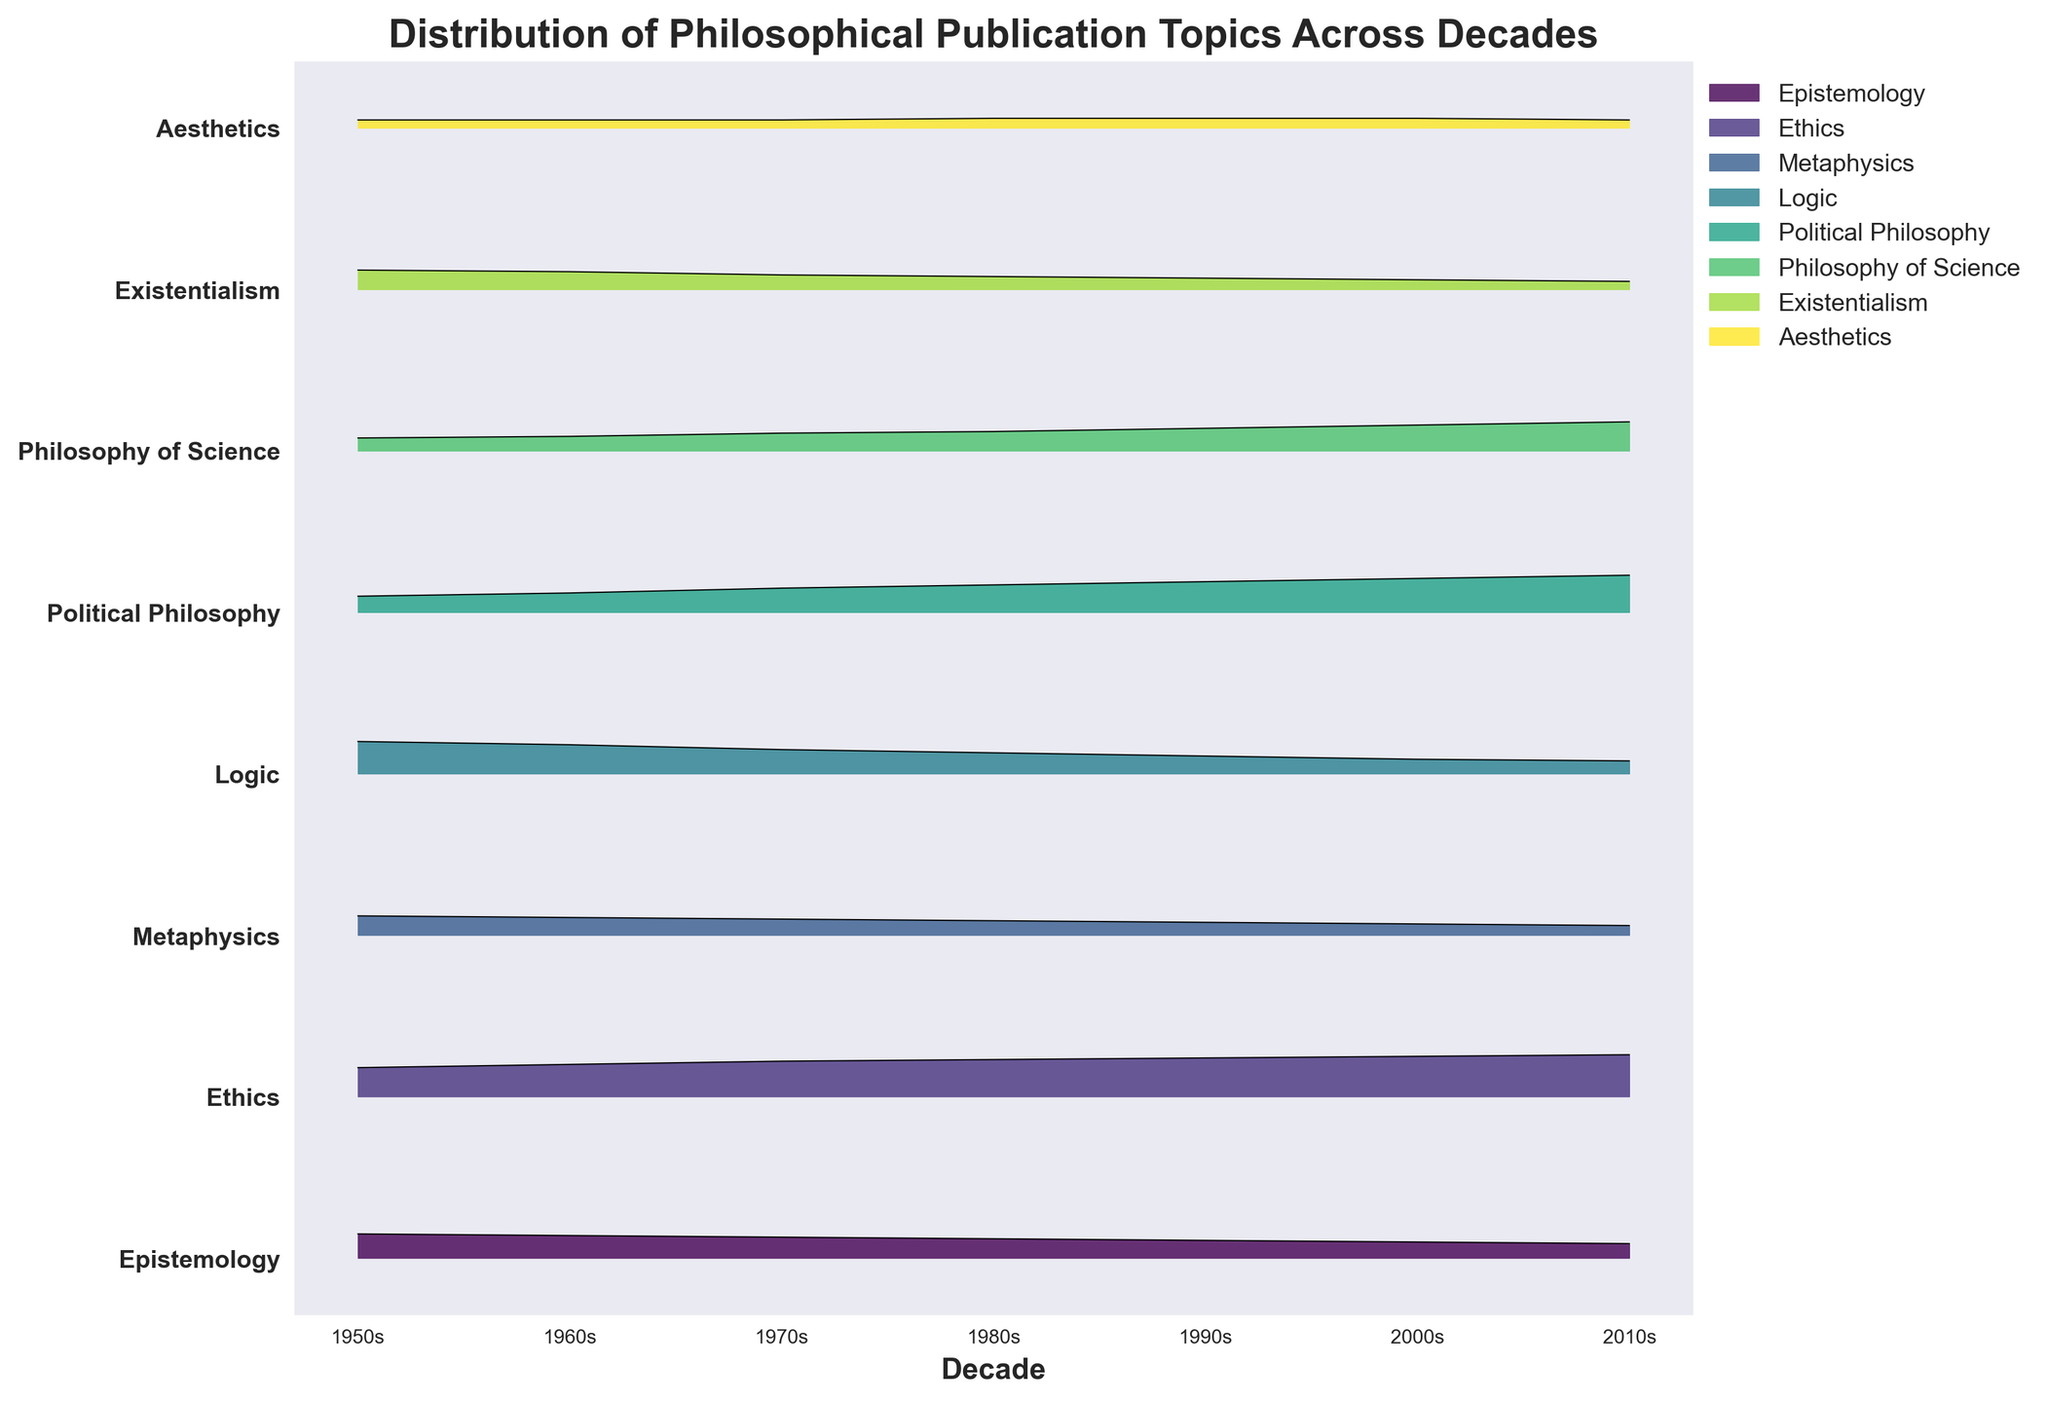What is the title of the figure? The title is written at the top of the plot. Titles are typically large and bold, making them easy to spot.
Answer: Distribution of Philosophical Publication Topics Across Decades How many decades are represented along the x-axis? The x-axis shows a list of decades, each marked at an interval. Counting these intervals or labels gives the total number of decades.
Answer: 7 Which topic had the highest proportion of publications in the 2010s? By observing the highest point on the y-axis for the 2010s data, we can identify the corresponding topic. The legend helps to decode which color represents which topic.
Answer: Ethics Which two topics had the most significant increase in publication proportion from the 1950s to the 2010s? To determine this, we compare the heights of the ridgeline plots for each topic between the two decades and identify the two with the greatest difference.
Answer: Political Philosophy and Philosophy of Science Did the proportion of publications in Logic increase or decrease over the decades? By following the curve from left (1950s) to right (2010s), we can observe if the line trend for Logic is going downwards (declining) or upwards (increasing).
Answer: Decrease What is the trend for the topic of Metaphysics from the 1950s to the 2010s? We look at the Metaphysics line and see if it generally increases or decreases across the decades shown on the x-axis from 1950s to 2010s.
Answer: Decrease By how much did the proportion of publications in Ethics increase from the 1950s to the 2010s? We note the proportion values for Ethics in the 1950s and 2010s and then subtract the 1950s value from the 2010s value to get the increase.
Answer: 0.08 Which topic had the smallest change in publication proportion between the 1950s and 2010s? This requires comparing the difference in proportions for each topic between the two decades and identifying the smallest change.
Answer: Aesthetics What did the publication trends look like for Existentialism over the decades? We need to track the curve associated with Existentialism from the 1950s to the 2010s. By observing the rise and fall of this curve, we can describe the trend.
Answer: Decrease Which decades saw the highest increase in publications for Political Philosophy? We compare the differences in proportion values of Political Philosophy between consecutive decades and identify the decade with the maximum increase.
Answer: 2000s to 2010s When did the Philosophy of Science see the most rapid growth? A rapid growth can be identified by a significant upward shift in the curve for Philosophy of Science in comparison to other decades. We assess the intervals where this growth is evident.
Answer: 2000s to 2010s 